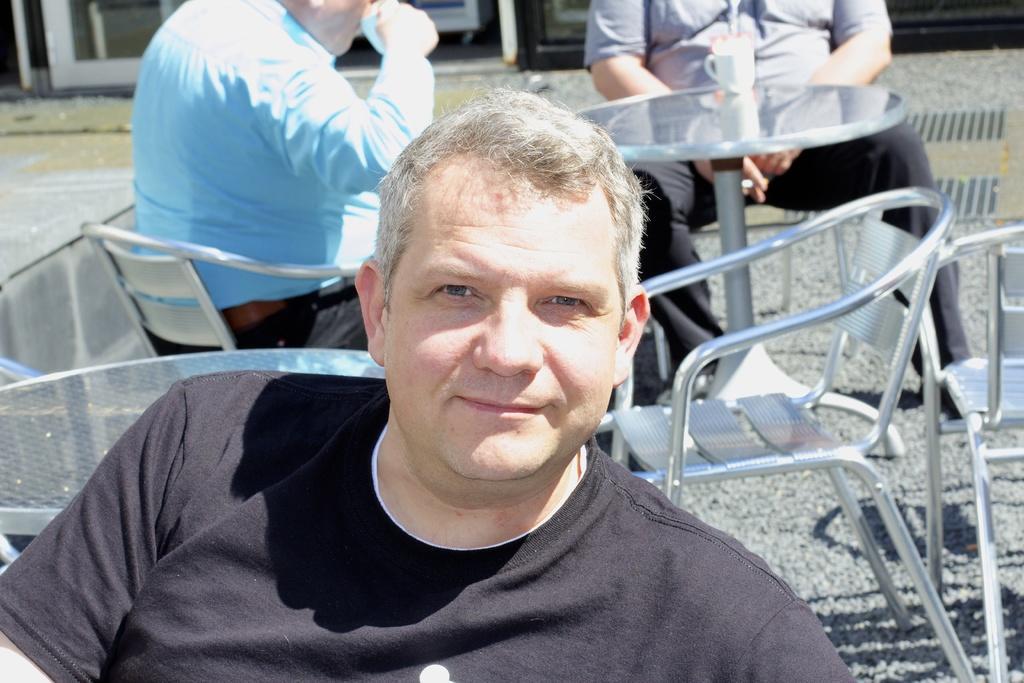Describe this image in one or two sentences. In this image in front there is a person sitting on the chair. Behind him there are two other people sitting on the chairs. In front of them there is a table and on top of it there is a cup. In the background of the image there is a building. 